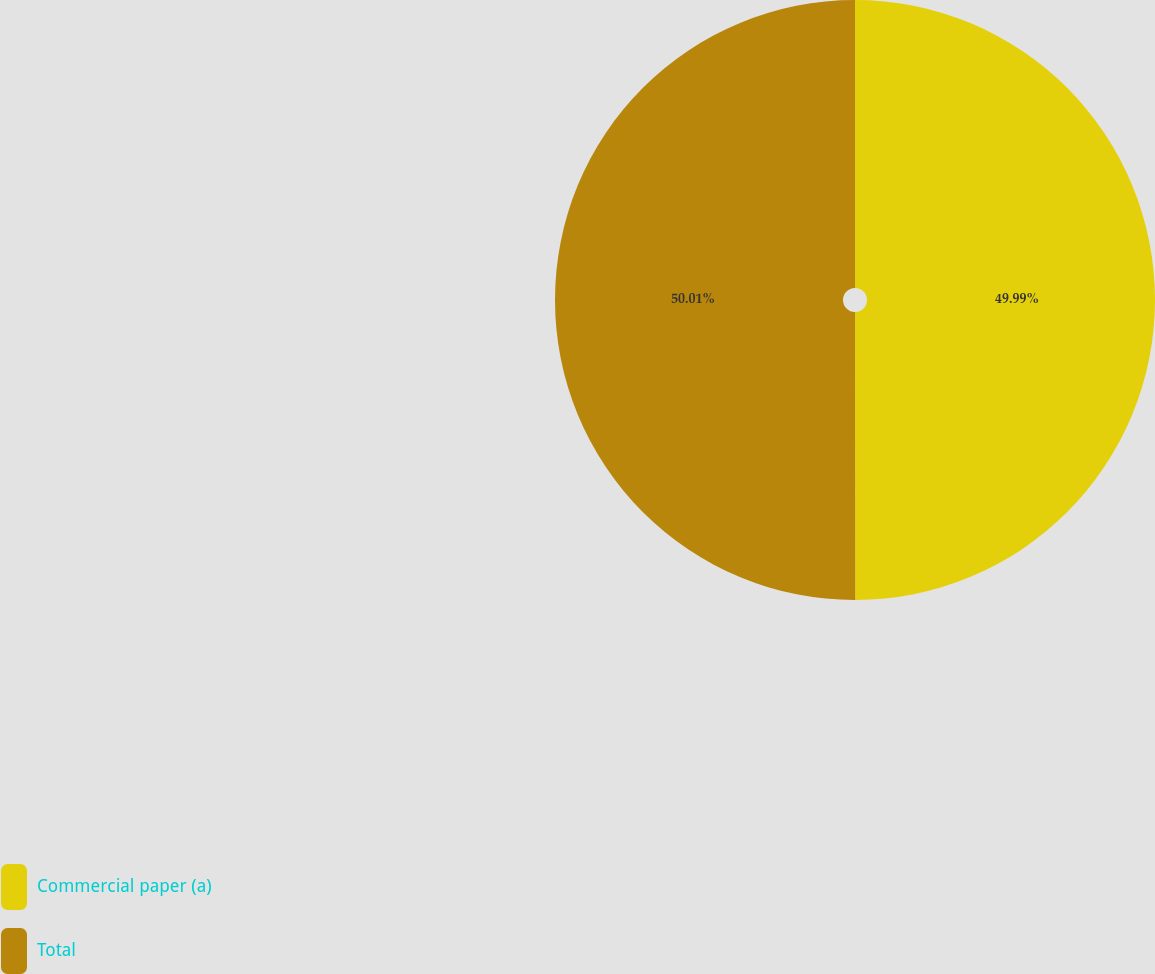Convert chart. <chart><loc_0><loc_0><loc_500><loc_500><pie_chart><fcel>Commercial paper (a)<fcel>Total<nl><fcel>49.99%<fcel>50.01%<nl></chart> 